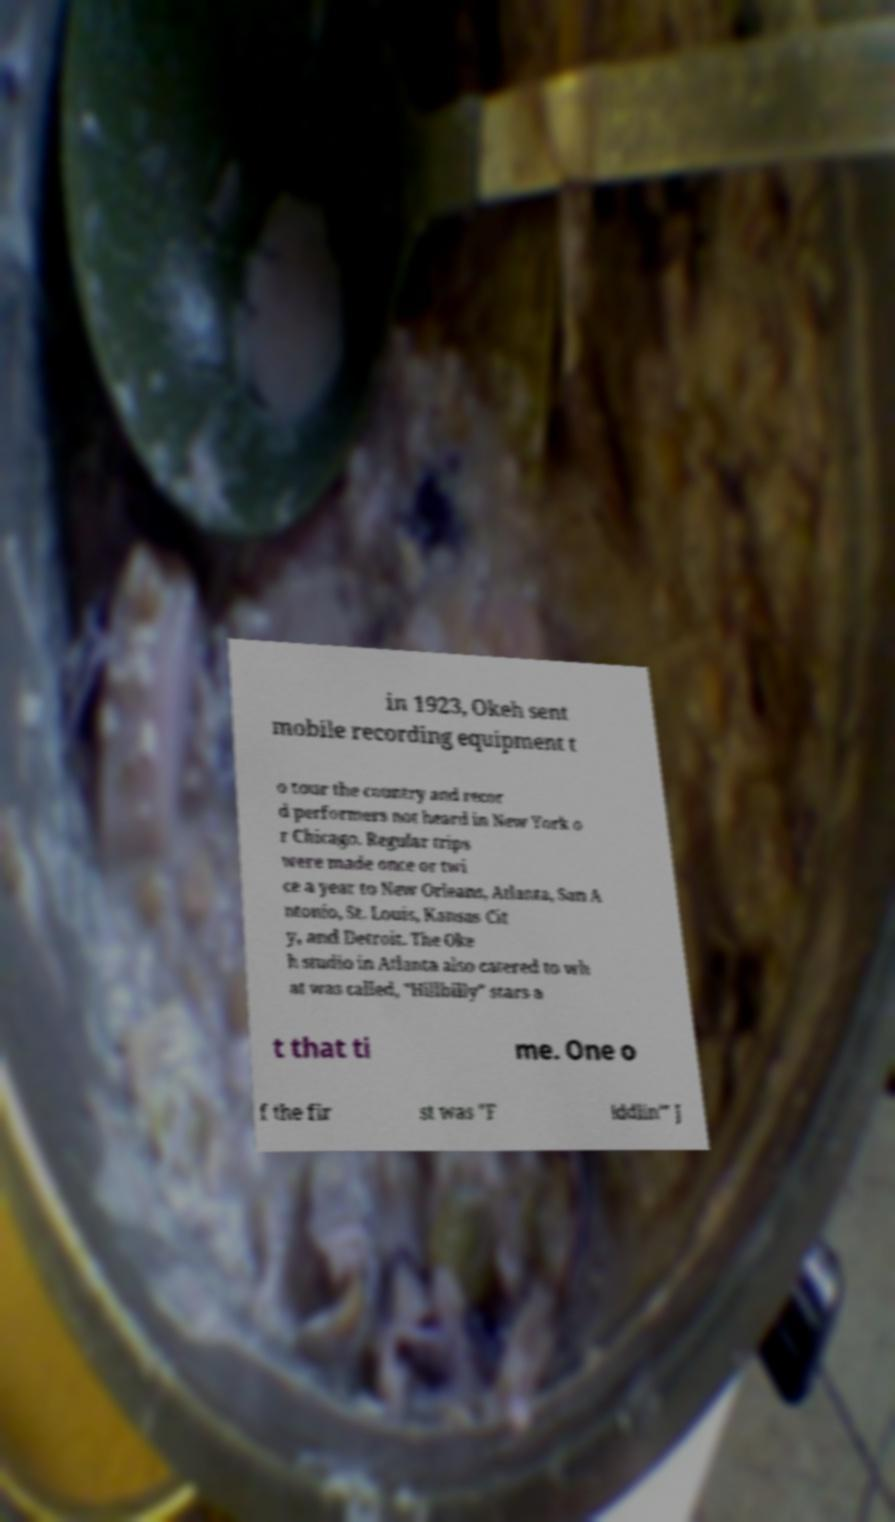Please identify and transcribe the text found in this image. in 1923, Okeh sent mobile recording equipment t o tour the country and recor d performers not heard in New York o r Chicago. Regular trips were made once or twi ce a year to New Orleans, Atlanta, San A ntonio, St. Louis, Kansas Cit y, and Detroit. The Oke h studio in Atlanta also catered to wh at was called, "Hillbilly" stars a t that ti me. One o f the fir st was "F iddlin'" J 